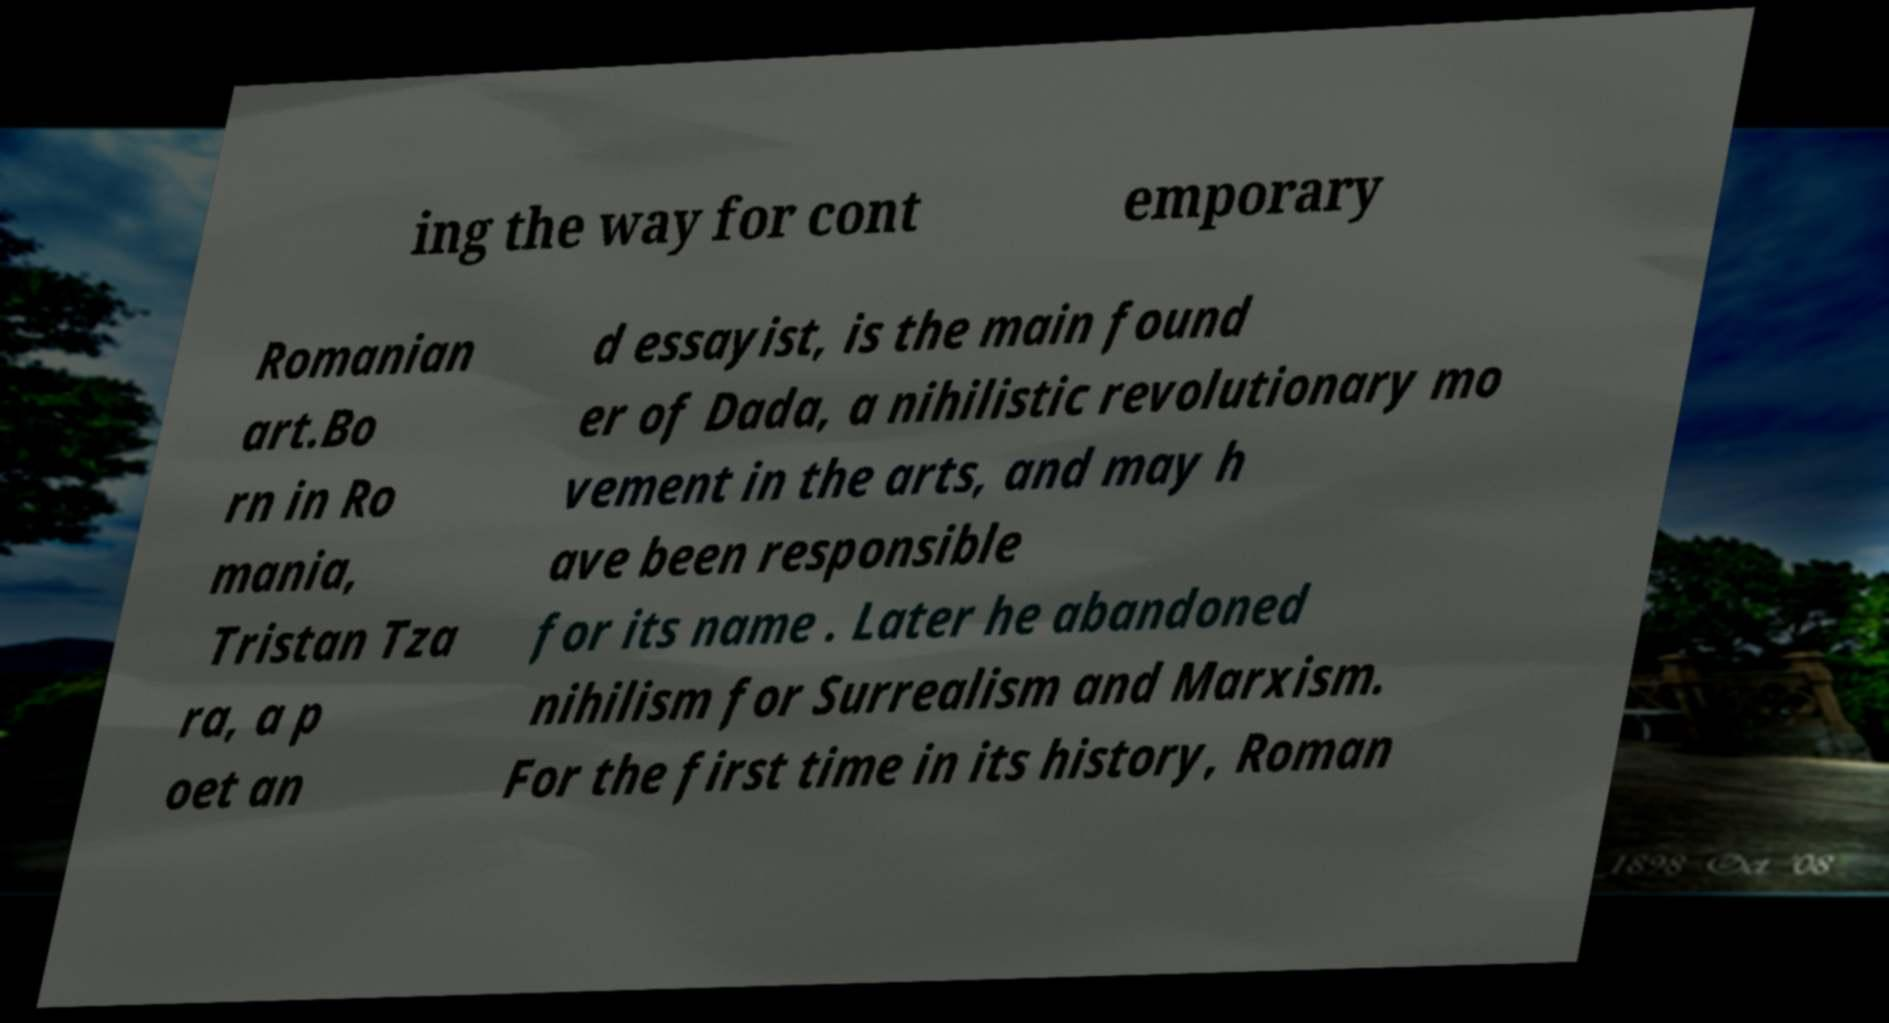There's text embedded in this image that I need extracted. Can you transcribe it verbatim? ing the way for cont emporary Romanian art.Bo rn in Ro mania, Tristan Tza ra, a p oet an d essayist, is the main found er of Dada, a nihilistic revolutionary mo vement in the arts, and may h ave been responsible for its name . Later he abandoned nihilism for Surrealism and Marxism. For the first time in its history, Roman 